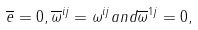<formula> <loc_0><loc_0><loc_500><loc_500>\overline { e } = 0 , \overline { \omega } ^ { i j } = \omega ^ { i j } a n d \overline { \omega } ^ { 1 j } = 0 ,</formula> 